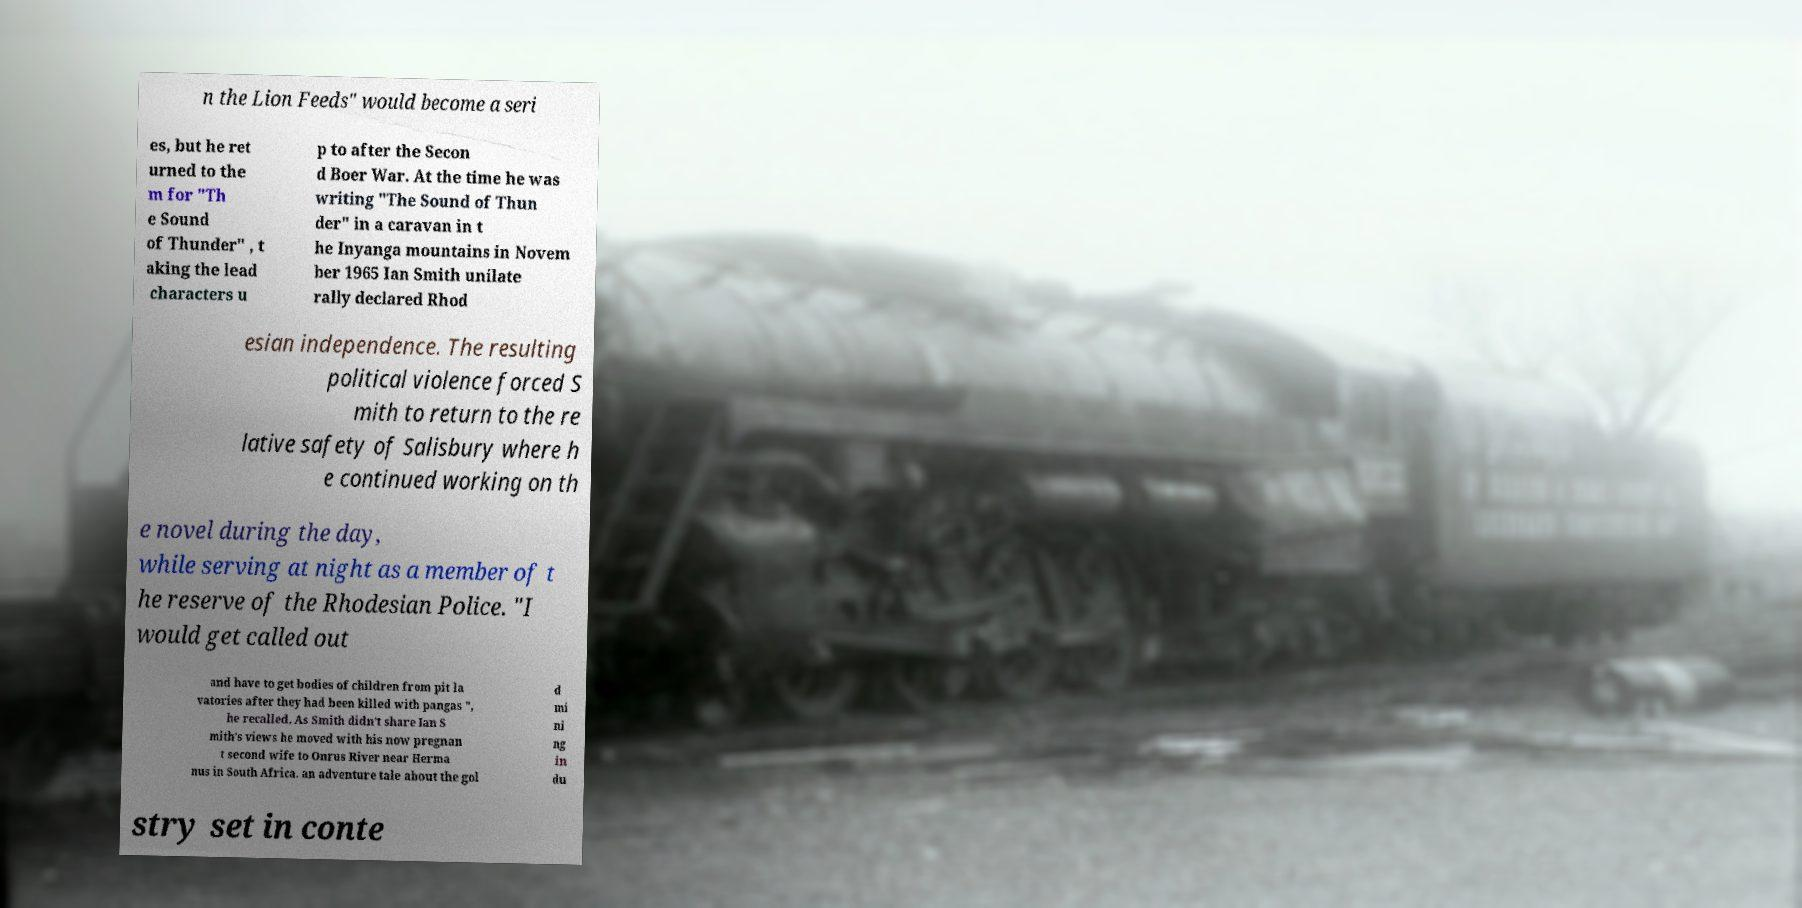What messages or text are displayed in this image? I need them in a readable, typed format. n the Lion Feeds" would become a seri es, but he ret urned to the m for "Th e Sound of Thunder" , t aking the lead characters u p to after the Secon d Boer War. At the time he was writing "The Sound of Thun der" in a caravan in t he Inyanga mountains in Novem ber 1965 Ian Smith unilate rally declared Rhod esian independence. The resulting political violence forced S mith to return to the re lative safety of Salisbury where h e continued working on th e novel during the day, while serving at night as a member of t he reserve of the Rhodesian Police. "I would get called out and have to get bodies of children from pit la vatories after they had been killed with pangas ", he recalled. As Smith didn’t share Ian S mith's views he moved with his now pregnan t second wife to Onrus River near Herma nus in South Africa. an adventure tale about the gol d mi ni ng in du stry set in conte 